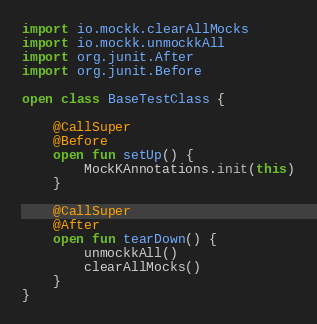Convert code to text. <code><loc_0><loc_0><loc_500><loc_500><_Kotlin_>import io.mockk.clearAllMocks
import io.mockk.unmockkAll
import org.junit.After
import org.junit.Before

open class BaseTestClass {

    @CallSuper
    @Before
    open fun setUp() {
        MockKAnnotations.init(this)
    }

    @CallSuper
    @After
    open fun tearDown() {
        unmockkAll()
        clearAllMocks()
    }
}
</code> 